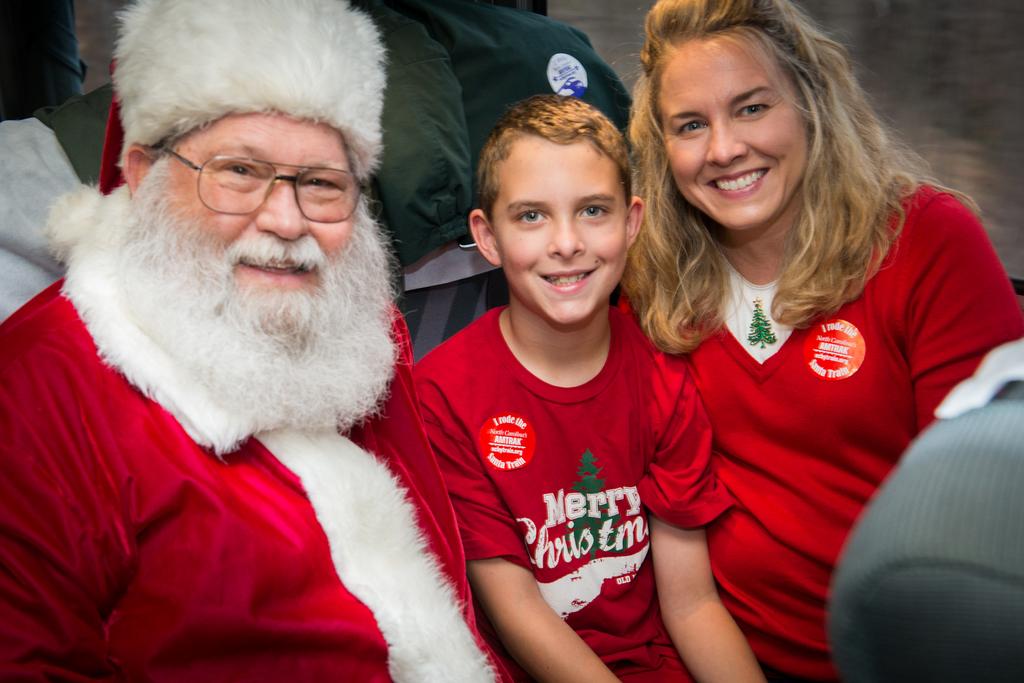What does the top of the sticker say?
Give a very brief answer. I rode the. 